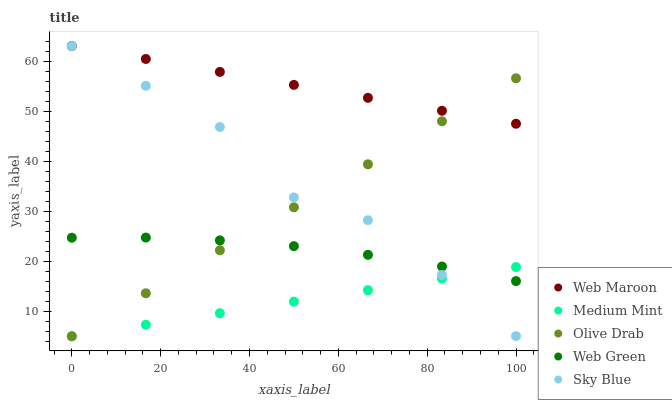Does Medium Mint have the minimum area under the curve?
Answer yes or no. Yes. Does Web Maroon have the maximum area under the curve?
Answer yes or no. Yes. Does Sky Blue have the minimum area under the curve?
Answer yes or no. No. Does Sky Blue have the maximum area under the curve?
Answer yes or no. No. Is Medium Mint the smoothest?
Answer yes or no. Yes. Is Sky Blue the roughest?
Answer yes or no. Yes. Is Web Maroon the smoothest?
Answer yes or no. No. Is Web Maroon the roughest?
Answer yes or no. No. Does Medium Mint have the lowest value?
Answer yes or no. Yes. Does Sky Blue have the lowest value?
Answer yes or no. No. Does Web Maroon have the highest value?
Answer yes or no. Yes. Does Web Green have the highest value?
Answer yes or no. No. Is Web Green less than Web Maroon?
Answer yes or no. Yes. Is Web Maroon greater than Web Green?
Answer yes or no. Yes. Does Web Green intersect Medium Mint?
Answer yes or no. Yes. Is Web Green less than Medium Mint?
Answer yes or no. No. Is Web Green greater than Medium Mint?
Answer yes or no. No. Does Web Green intersect Web Maroon?
Answer yes or no. No. 